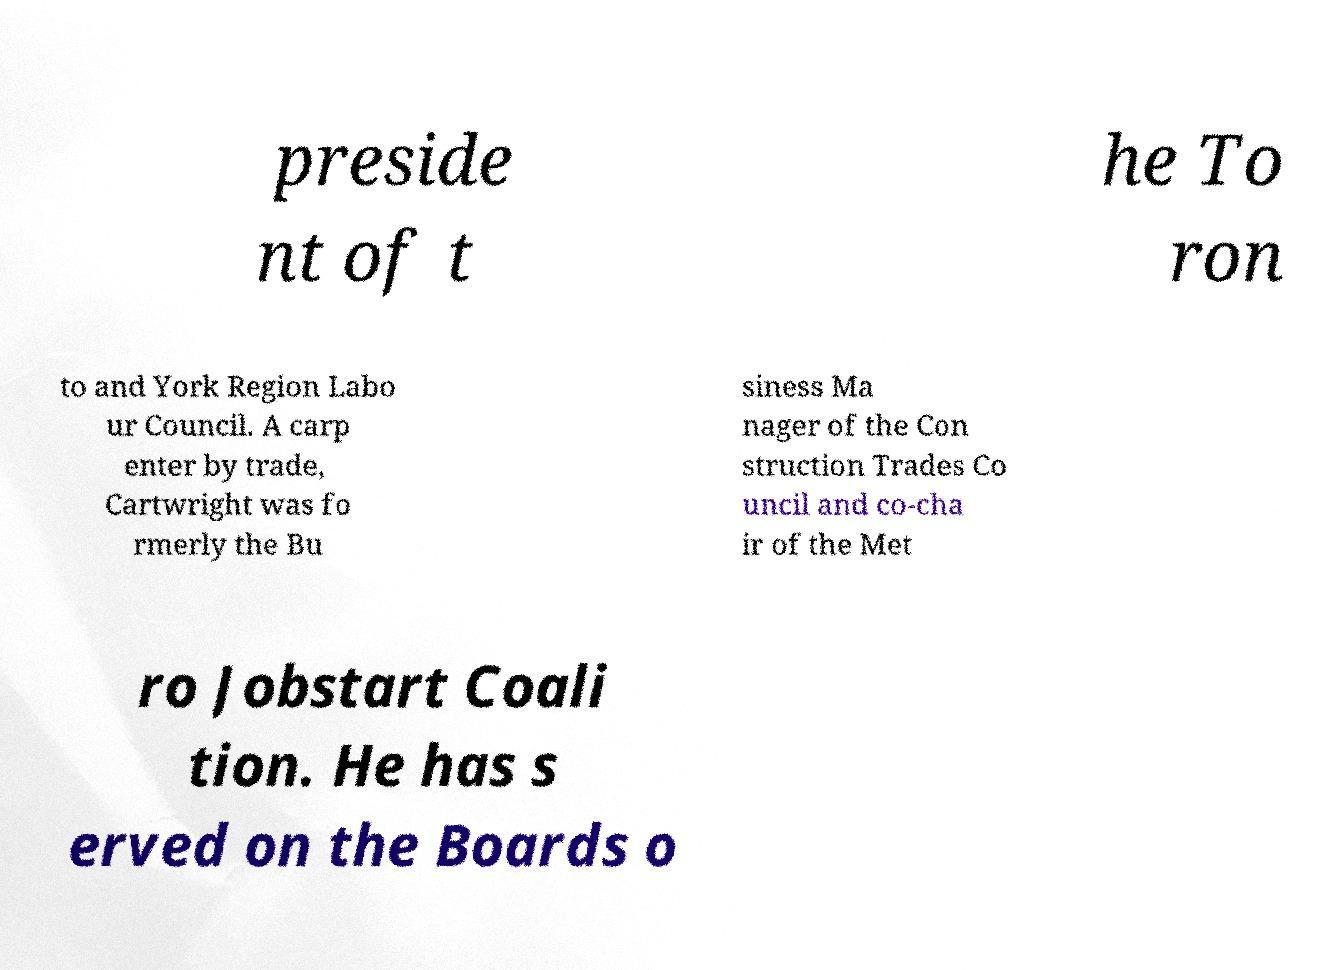Could you extract and type out the text from this image? preside nt of t he To ron to and York Region Labo ur Council. A carp enter by trade, Cartwright was fo rmerly the Bu siness Ma nager of the Con struction Trades Co uncil and co-cha ir of the Met ro Jobstart Coali tion. He has s erved on the Boards o 